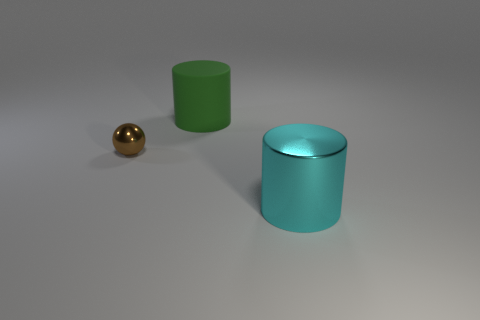There is a big thing behind the small shiny thing; what is its shape?
Give a very brief answer. Cylinder. There is a object that is to the right of the brown metallic sphere and to the left of the big metal object; what shape is it?
Keep it short and to the point. Cylinder. What number of green objects are matte things or tiny objects?
Offer a terse response. 1. There is a metallic object that is on the left side of the cylinder in front of the ball; what size is it?
Your answer should be compact. Small. There is a cyan cylinder that is the same size as the green cylinder; what is it made of?
Give a very brief answer. Metal. What number of other objects are there of the same size as the matte thing?
Make the answer very short. 1. What number of cylinders are cyan things or large brown matte objects?
Provide a short and direct response. 1. Is there any other thing that is made of the same material as the green thing?
Make the answer very short. No. There is a big object that is on the left side of the cylinder that is in front of the large green matte cylinder that is behind the brown thing; what is it made of?
Your response must be concise. Rubber. What number of cyan things have the same material as the cyan cylinder?
Your response must be concise. 0. 